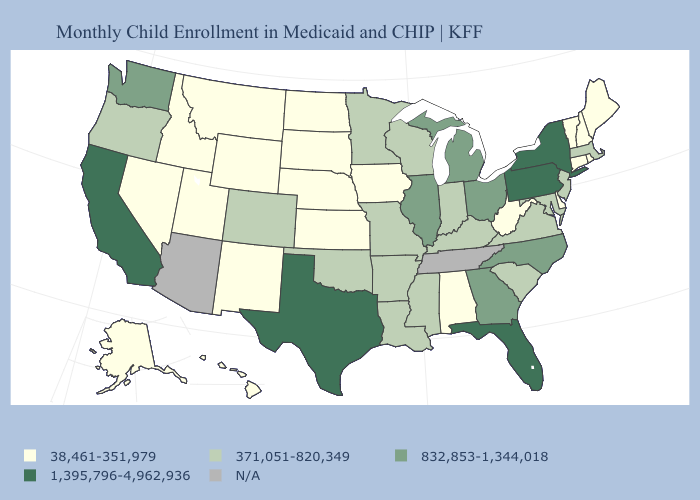What is the value of South Carolina?
Be succinct. 371,051-820,349. What is the highest value in the USA?
Write a very short answer. 1,395,796-4,962,936. Among the states that border Vermont , does New Hampshire have the highest value?
Concise answer only. No. Among the states that border Washington , does Oregon have the lowest value?
Keep it brief. No. Among the states that border Louisiana , which have the lowest value?
Answer briefly. Arkansas, Mississippi. What is the value of Wyoming?
Write a very short answer. 38,461-351,979. What is the value of Georgia?
Write a very short answer. 832,853-1,344,018. What is the highest value in states that border Maine?
Give a very brief answer. 38,461-351,979. Name the states that have a value in the range N/A?
Answer briefly. Arizona, Tennessee. Name the states that have a value in the range 371,051-820,349?
Give a very brief answer. Arkansas, Colorado, Indiana, Kentucky, Louisiana, Maryland, Massachusetts, Minnesota, Mississippi, Missouri, New Jersey, Oklahoma, Oregon, South Carolina, Virginia, Wisconsin. Name the states that have a value in the range 38,461-351,979?
Write a very short answer. Alabama, Alaska, Connecticut, Delaware, Hawaii, Idaho, Iowa, Kansas, Maine, Montana, Nebraska, Nevada, New Hampshire, New Mexico, North Dakota, Rhode Island, South Dakota, Utah, Vermont, West Virginia, Wyoming. Does Arkansas have the lowest value in the USA?
Write a very short answer. No. Among the states that border Oregon , which have the lowest value?
Quick response, please. Idaho, Nevada. 